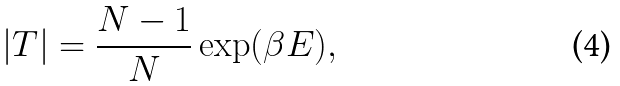Convert formula to latex. <formula><loc_0><loc_0><loc_500><loc_500>| T | = \frac { N - 1 } { N } \exp ( \beta E ) ,</formula> 